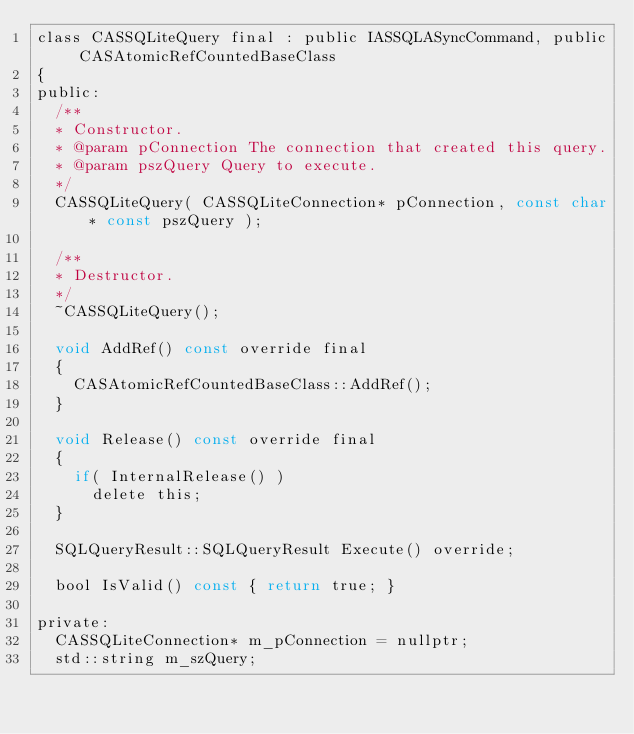<code> <loc_0><loc_0><loc_500><loc_500><_C_>class CASSQLiteQuery final : public IASSQLASyncCommand, public CASAtomicRefCountedBaseClass
{
public:
	/**
	*	Constructor.
	*	@param pConnection The connection that created this query.
	*	@param pszQuery Query to execute.
	*/
	CASSQLiteQuery( CASSQLiteConnection* pConnection, const char* const pszQuery );

	/**
	*	Destructor.
	*/
	~CASSQLiteQuery();

	void AddRef() const override final
	{
		CASAtomicRefCountedBaseClass::AddRef();
	}

	void Release() const override final
	{
		if( InternalRelease() )
			delete this;
	}

	SQLQueryResult::SQLQueryResult Execute() override;

	bool IsValid() const { return true; }

private:
	CASSQLiteConnection* m_pConnection = nullptr;
	std::string m_szQuery;
</code> 